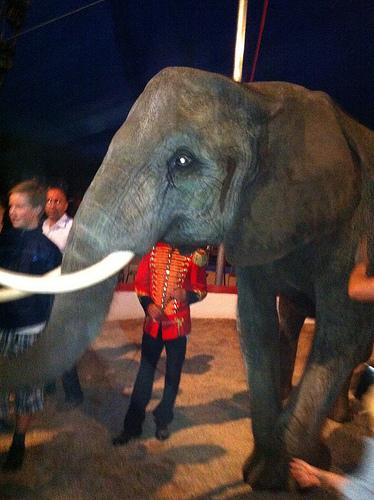Count the number of tusks the elephant has. The elephant has two tusks. What type of clothing does the man with an ornate uniform have on? The man has a red coat and dark pants on. Describe the teenager's outfit in the image. The teenager is wearing a jacket and plaid shorts. What is the color of the elephant in the image? The elephant is gray. Mention one interesting detail about the elephant's appearance. Light is reflecting on the elephant's eye. In a few words, describe the scene in the image. Circus scene with people and a large elephant. Identify the main event happening in the image. People are gathered around a large elephant at a circus. Does the image have a bright or dark atmosphere? The image has a dark atmosphere. What is the color of the ground in the image? The ground is brown. Are there any interactions between people and the elephant in the image? If so, describe them. Yes, a person is touching the elephant. Can you see any green grass on the ground? The captions explicitly describe the ground as brown and covered in dirt in the arena, without mentioning any presence of green grass. Is the man wearing a green uniform in the image? Several captions mention the man's ornate uniform, but all of them describe it as red, not green. Is there a woman with long hair in the picture? There is no mention of a woman or any person with long hair in the captions. Various captions mention men, a boy, and a teenager, but no women. Do you see any yellow shoes in the image? A pair of blurry shoes is described, but there is no mention of their color. Therefore, mentioning the color yellow could be misleading. Can you spot a small elephant in the photograph? Captions mention a large elephant multiple times, but there is no mention of a small elephant. Is the elephant's eye closed in the photo? One of the captions explicitly states that "the elephants eye is open", suggesting the eye is not closed. 